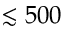<formula> <loc_0><loc_0><loc_500><loc_500>\lesssim 5 0 0</formula> 